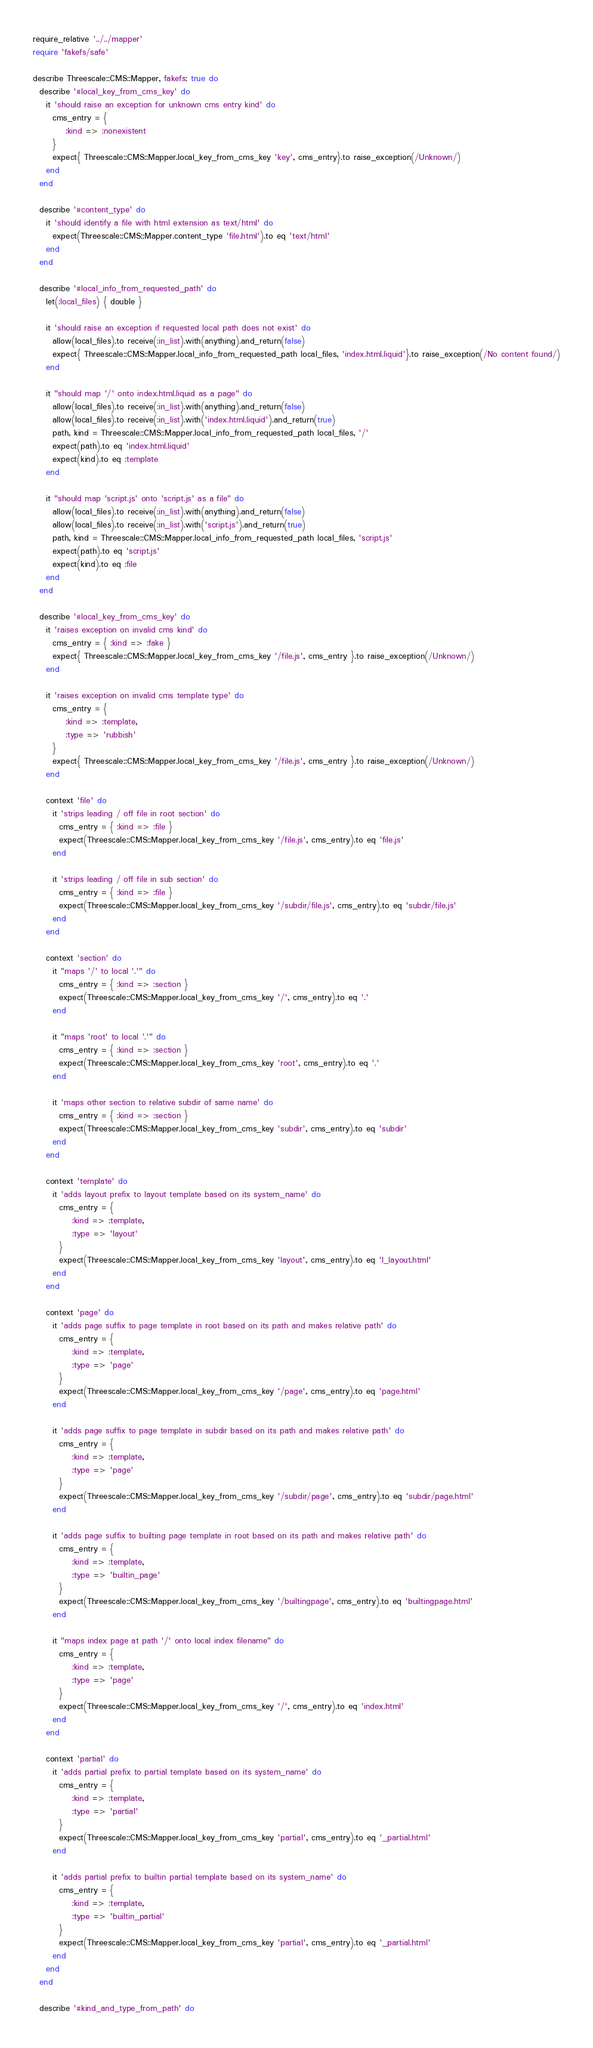<code> <loc_0><loc_0><loc_500><loc_500><_Ruby_>require_relative '../../mapper'
require 'fakefs/safe'

describe Threescale::CMS::Mapper, fakefs: true do
  describe '#local_key_from_cms_key' do
    it 'should raise an exception for unknown cms entry kind' do
      cms_entry = {
          :kind => :nonexistent
      }
      expect{ Threescale::CMS::Mapper.local_key_from_cms_key 'key', cms_entry}.to raise_exception(/Unknown/)
    end
  end

  describe '#content_type' do
    it 'should identify a file with html extension as text/html' do
      expect(Threescale::CMS::Mapper.content_type 'file.html').to eq 'text/html'
    end
  end

  describe '#local_info_from_requested_path' do
    let(:local_files) { double }

    it 'should raise an exception if requested local path does not exist' do
      allow(local_files).to receive(:in_list).with(anything).and_return(false)
      expect{ Threescale::CMS::Mapper.local_info_from_requested_path local_files, 'index.html.liquid'}.to raise_exception(/No content found/)
    end

    it "should map '/' onto index.html.liquid as a page" do
      allow(local_files).to receive(:in_list).with(anything).and_return(false)
      allow(local_files).to receive(:in_list).with('index.html.liquid').and_return(true)
      path, kind = Threescale::CMS::Mapper.local_info_from_requested_path local_files, '/'
      expect(path).to eq 'index.html.liquid'
      expect(kind).to eq :template
    end

    it "should map 'script.js' onto 'script.js' as a file" do
      allow(local_files).to receive(:in_list).with(anything).and_return(false)
      allow(local_files).to receive(:in_list).with('script.js').and_return(true)
      path, kind = Threescale::CMS::Mapper.local_info_from_requested_path local_files, 'script.js'
      expect(path).to eq 'script.js'
      expect(kind).to eq :file
    end
  end

  describe '#local_key_from_cms_key' do
    it 'raises exception on invalid cms kind' do
      cms_entry = { :kind => :fake }
      expect{ Threescale::CMS::Mapper.local_key_from_cms_key '/file.js', cms_entry }.to raise_exception(/Unknown/)
    end

    it 'raises exception on invalid cms template type' do
      cms_entry = {
          :kind => :template,
          :type => 'rubbish'
      }
      expect{ Threescale::CMS::Mapper.local_key_from_cms_key '/file.js', cms_entry }.to raise_exception(/Unknown/)
    end

    context 'file' do
      it 'strips leading / off file in root section' do
        cms_entry = { :kind => :file }
        expect(Threescale::CMS::Mapper.local_key_from_cms_key '/file.js', cms_entry).to eq 'file.js'
      end

      it 'strips leading / off file in sub section' do
        cms_entry = { :kind => :file }
        expect(Threescale::CMS::Mapper.local_key_from_cms_key '/subdir/file.js', cms_entry).to eq 'subdir/file.js'
      end
    end

    context 'section' do
      it "maps '/' to local '.'" do
        cms_entry = { :kind => :section }
        expect(Threescale::CMS::Mapper.local_key_from_cms_key '/', cms_entry).to eq '.'
      end

      it "maps 'root' to local '.'" do
        cms_entry = { :kind => :section }
        expect(Threescale::CMS::Mapper.local_key_from_cms_key 'root', cms_entry).to eq '.'
      end

      it 'maps other section to relative subdir of same name' do
        cms_entry = { :kind => :section }
        expect(Threescale::CMS::Mapper.local_key_from_cms_key 'subdir', cms_entry).to eq 'subdir'
      end
    end

    context 'template' do
      it 'adds layout prefix to layout template based on its system_name' do
        cms_entry = {
            :kind => :template,
            :type => 'layout'
        }
        expect(Threescale::CMS::Mapper.local_key_from_cms_key 'layout', cms_entry).to eq 'l_layout.html'
      end
    end

    context 'page' do
      it 'adds page suffix to page template in root based on its path and makes relative path' do
        cms_entry = {
            :kind => :template,
            :type => 'page'
        }
        expect(Threescale::CMS::Mapper.local_key_from_cms_key '/page', cms_entry).to eq 'page.html'
      end

      it 'adds page suffix to page template in subdir based on its path and makes relative path' do
        cms_entry = {
            :kind => :template,
            :type => 'page'
        }
        expect(Threescale::CMS::Mapper.local_key_from_cms_key '/subdir/page', cms_entry).to eq 'subdir/page.html'
      end

      it 'adds page suffix to builting page template in root based on its path and makes relative path' do
        cms_entry = {
            :kind => :template,
            :type => 'builtin_page'
        }
        expect(Threescale::CMS::Mapper.local_key_from_cms_key '/builtingpage', cms_entry).to eq 'builtingpage.html'
      end

      it "maps index page at path '/' onto local index filename" do
        cms_entry = {
            :kind => :template,
            :type => 'page'
        }
        expect(Threescale::CMS::Mapper.local_key_from_cms_key '/', cms_entry).to eq 'index.html'
      end
    end

    context 'partial' do
      it 'adds partial prefix to partial template based on its system_name' do
        cms_entry = {
            :kind => :template,
            :type => 'partial'
        }
        expect(Threescale::CMS::Mapper.local_key_from_cms_key 'partial', cms_entry).to eq '_partial.html'
      end

      it 'adds partial prefix to builtin partial template based on its system_name' do
        cms_entry = {
            :kind => :template,
            :type => 'builtin_partial'
        }
        expect(Threescale::CMS::Mapper.local_key_from_cms_key 'partial', cms_entry).to eq '_partial.html'
      end
    end
  end

  describe '#kind_and_type_from_path' do</code> 